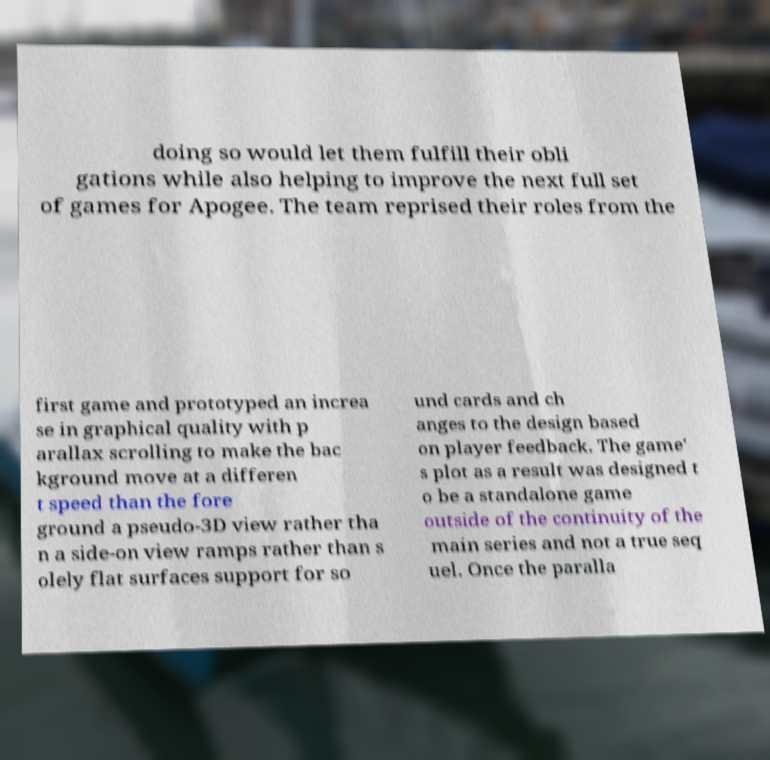Could you extract and type out the text from this image? doing so would let them fulfill their obli gations while also helping to improve the next full set of games for Apogee. The team reprised their roles from the first game and prototyped an increa se in graphical quality with p arallax scrolling to make the bac kground move at a differen t speed than the fore ground a pseudo-3D view rather tha n a side-on view ramps rather than s olely flat surfaces support for so und cards and ch anges to the design based on player feedback. The game' s plot as a result was designed t o be a standalone game outside of the continuity of the main series and not a true seq uel. Once the paralla 